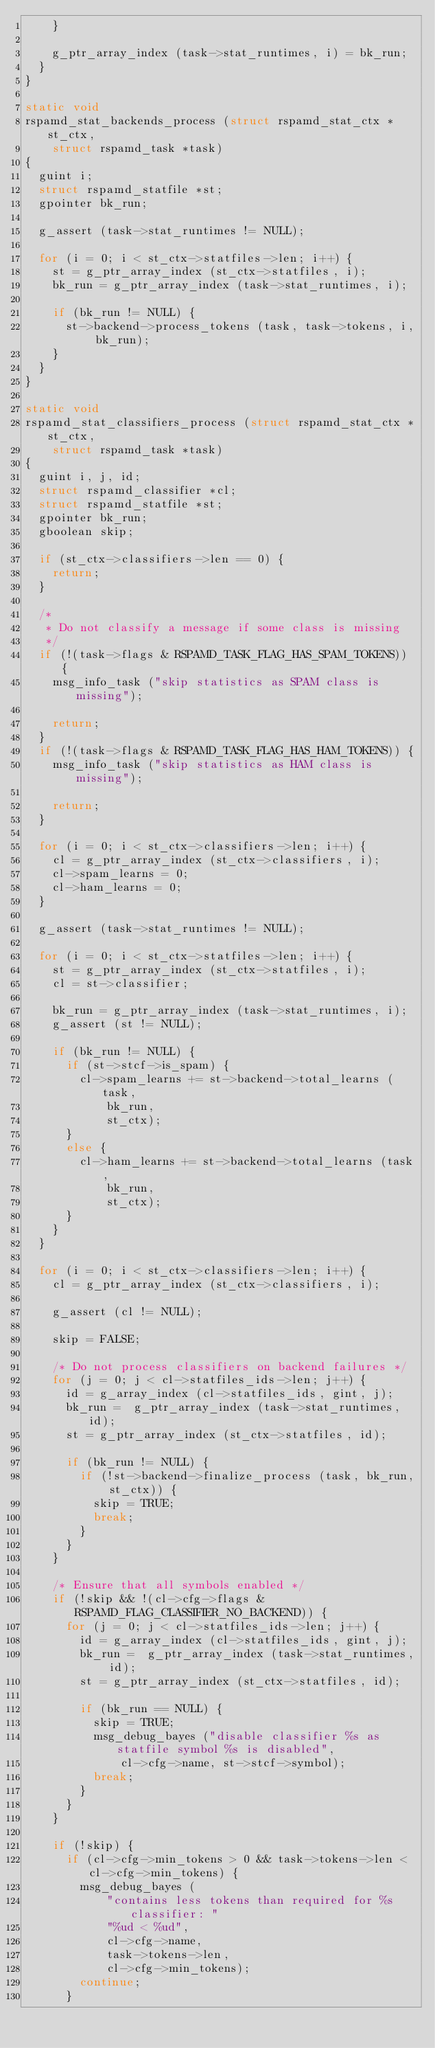Convert code to text. <code><loc_0><loc_0><loc_500><loc_500><_C_>		}

		g_ptr_array_index (task->stat_runtimes, i) = bk_run;
	}
}

static void
rspamd_stat_backends_process (struct rspamd_stat_ctx *st_ctx,
		struct rspamd_task *task)
{
	guint i;
	struct rspamd_statfile *st;
	gpointer bk_run;

	g_assert (task->stat_runtimes != NULL);

	for (i = 0; i < st_ctx->statfiles->len; i++) {
		st = g_ptr_array_index (st_ctx->statfiles, i);
		bk_run = g_ptr_array_index (task->stat_runtimes, i);

		if (bk_run != NULL) {
			st->backend->process_tokens (task, task->tokens, i, bk_run);
		}
	}
}

static void
rspamd_stat_classifiers_process (struct rspamd_stat_ctx *st_ctx,
		struct rspamd_task *task)
{
	guint i, j, id;
	struct rspamd_classifier *cl;
	struct rspamd_statfile *st;
	gpointer bk_run;
	gboolean skip;

	if (st_ctx->classifiers->len == 0) {
		return;
	}

	/*
	 * Do not classify a message if some class is missing
	 */
	if (!(task->flags & RSPAMD_TASK_FLAG_HAS_SPAM_TOKENS)) {
		msg_info_task ("skip statistics as SPAM class is missing");

		return;
	}
	if (!(task->flags & RSPAMD_TASK_FLAG_HAS_HAM_TOKENS)) {
		msg_info_task ("skip statistics as HAM class is missing");

		return;
	}

	for (i = 0; i < st_ctx->classifiers->len; i++) {
		cl = g_ptr_array_index (st_ctx->classifiers, i);
		cl->spam_learns = 0;
		cl->ham_learns = 0;
	}

	g_assert (task->stat_runtimes != NULL);

	for (i = 0; i < st_ctx->statfiles->len; i++) {
		st = g_ptr_array_index (st_ctx->statfiles, i);
		cl = st->classifier;

		bk_run = g_ptr_array_index (task->stat_runtimes, i);
		g_assert (st != NULL);

		if (bk_run != NULL) {
			if (st->stcf->is_spam) {
				cl->spam_learns += st->backend->total_learns (task,
						bk_run,
						st_ctx);
			}
			else {
				cl->ham_learns += st->backend->total_learns (task,
						bk_run,
						st_ctx);
			}
		}
	}

	for (i = 0; i < st_ctx->classifiers->len; i++) {
		cl = g_ptr_array_index (st_ctx->classifiers, i);

		g_assert (cl != NULL);

		skip = FALSE;

		/* Do not process classifiers on backend failures */
		for (j = 0; j < cl->statfiles_ids->len; j++) {
			id = g_array_index (cl->statfiles_ids, gint, j);
			bk_run =  g_ptr_array_index (task->stat_runtimes, id);
			st = g_ptr_array_index (st_ctx->statfiles, id);

			if (bk_run != NULL) {
				if (!st->backend->finalize_process (task, bk_run, st_ctx)) {
					skip = TRUE;
					break;
				}
			}
		}

		/* Ensure that all symbols enabled */
		if (!skip && !(cl->cfg->flags & RSPAMD_FLAG_CLASSIFIER_NO_BACKEND)) {
			for (j = 0; j < cl->statfiles_ids->len; j++) {
				id = g_array_index (cl->statfiles_ids, gint, j);
				bk_run =  g_ptr_array_index (task->stat_runtimes, id);
				st = g_ptr_array_index (st_ctx->statfiles, id);

				if (bk_run == NULL) {
					skip = TRUE;
					msg_debug_bayes ("disable classifier %s as statfile symbol %s is disabled",
							cl->cfg->name, st->stcf->symbol);
					break;
				}
			}
		}

		if (!skip) {
			if (cl->cfg->min_tokens > 0 && task->tokens->len < cl->cfg->min_tokens) {
				msg_debug_bayes (
						"contains less tokens than required for %s classifier: "
						"%ud < %ud",
						cl->cfg->name,
						task->tokens->len,
						cl->cfg->min_tokens);
				continue;
			}</code> 